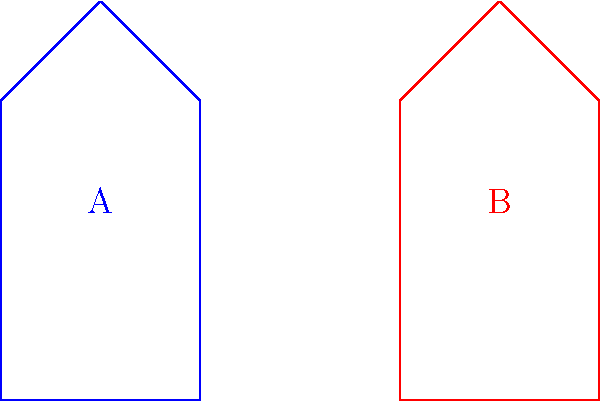Which of the following statements about the shapes of the two traditional GCC mosque domes (A and B) is correct?

a) The domes are congruent
b) The domes are similar but not congruent
c) The domes are neither congruent nor similar
d) There's not enough information to determine congruence or similarity To determine if the shapes are congruent, we need to analyze their properties:

1. Both shapes are pentagons with similar overall structure.
2. The base width of both shapes is 2 units (from 0 to 2 for A, and from 4 to 6 for B).
3. The height of both shapes is 4 units (from y=0 to y=4).
4. The apex of both domes is centered (at x=1 for A and x=5 for B).
5. The sides of both shapes appear to have the same slope.

Given that all corresponding sides and angles are equal, and the shapes have the same size and proportions, we can conclude that the two dome shapes are congruent.

Congruent shapes have the same size and shape, which means they can be superimposed on each other through translation, rotation, or reflection without any scaling.

In this case, shape B is a translation of shape A by 4 units to the right.
Answer: a) The domes are congruent 